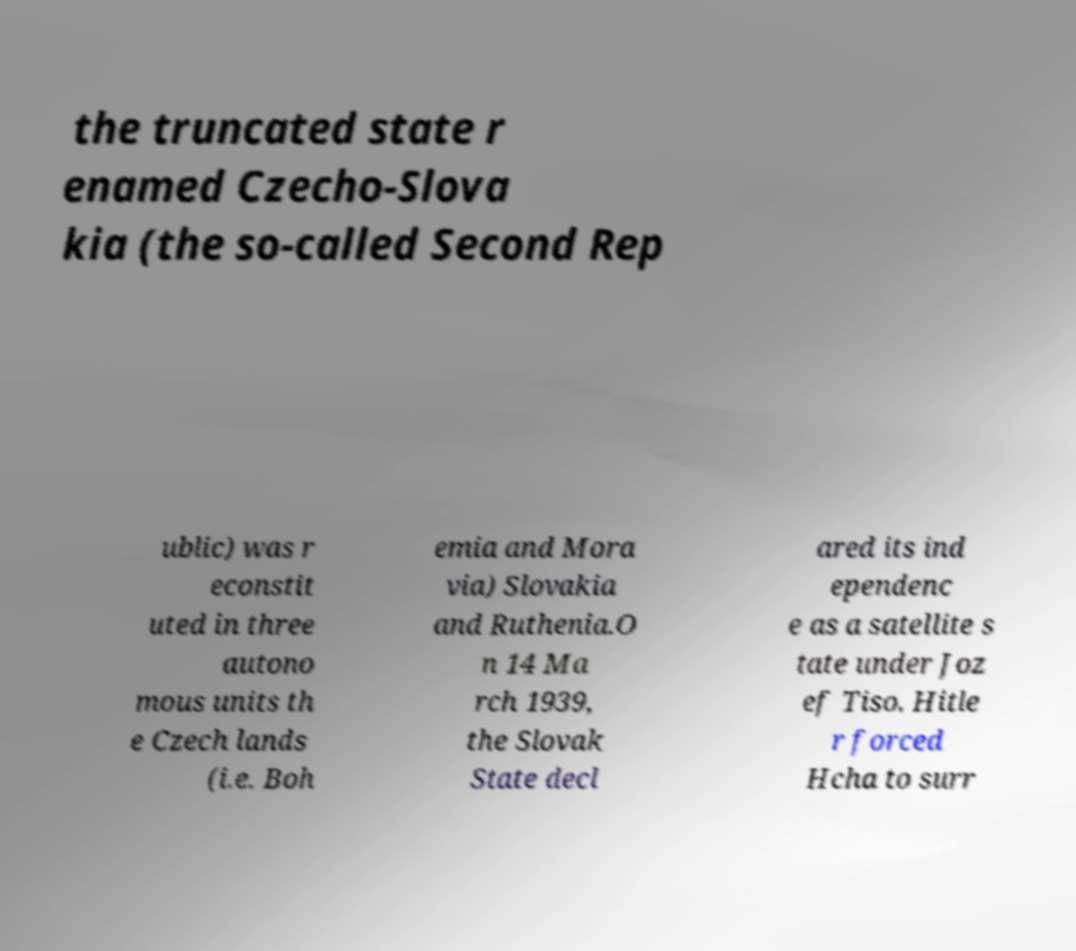Could you assist in decoding the text presented in this image and type it out clearly? the truncated state r enamed Czecho-Slova kia (the so-called Second Rep ublic) was r econstit uted in three autono mous units th e Czech lands (i.e. Boh emia and Mora via) Slovakia and Ruthenia.O n 14 Ma rch 1939, the Slovak State decl ared its ind ependenc e as a satellite s tate under Joz ef Tiso. Hitle r forced Hcha to surr 